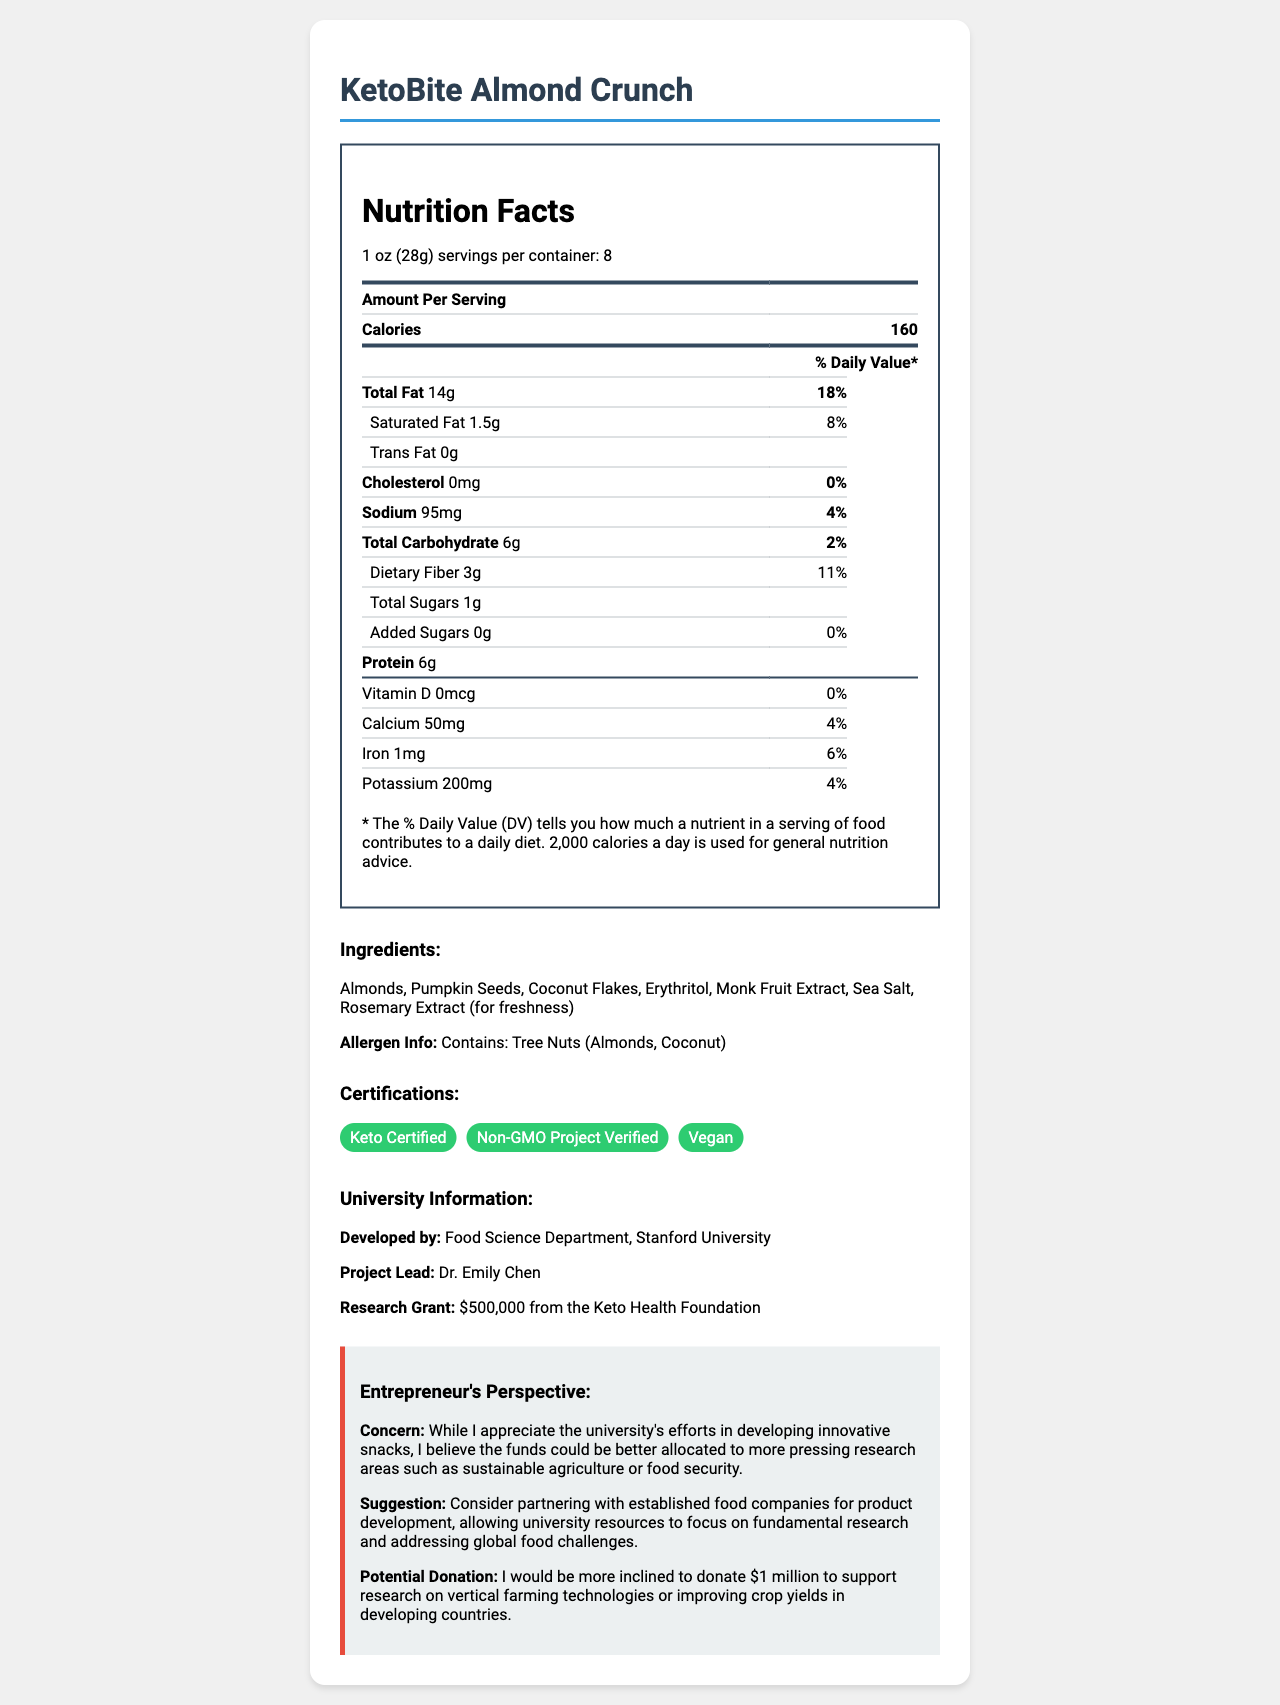what is the product name? The product name is listed at the top of the document.
Answer: KetoBite Almond Crunch how many servings are there per container? The document states that there are 8 servings per container.
Answer: 8 what is the amount of total fat per serving? The nutrition label lists the total fat as 14g per serving.
Answer: 14g which ingredients are used in the KetoBite Almond Crunch? The ingredients are listed under the "Ingredients" section.
Answer: Almonds, Pumpkin Seeds, Coconut Flakes, Erythritol, Monk Fruit Extract, Sea Salt, Rosemary Extract (for freshness) how much protein does each serving contain? The nutrition facts label specifies that there is 6g of protein per serving.
Answer: 6g which university developed this product? The university information section indicates that the product was developed by the Food Science Department at Stanford University.
Answer: Stanford University what is the research grant for the project? A. $100,000 B. $500,000 C. $1,000,000 D. $2,000,000 The university information section states that the research grant was $500,000 from the Keto Health Foundation.
Answer: B. $500,000 how much potassium is in each serving? A. 100mg B. 150mg C. 200mg D. 250mg The nutrition label lists 200mg of potassium per serving.
Answer: C. 200mg is the KetoBite Almond Crunch product vegan? The document includes a certification section which indicates that the product is Vegan.
Answer: Yes describe the entrepreneur's perspective provided in the document. The entrepreneur’s perspective is detailed in the section labeled "Entrepreneur's Perspective," discussing their concerns, suggestions, and potential donation.
Answer: The entrepreneur appreciates the university’s effort in developing innovative snacks but believes the funds could be better used in other research areas like sustainable agriculture or food security. The entrepreneur suggests partnering with established food companies to allow the university to focus on fundamental research. They would consider donating $1 million for vertical farming technologies or crop yield improvements in developing countries. does the product contain any trans fat? The nutrition facts indicate that the product contains 0g of trans fat per serving.
Answer: No how many certifications does the product have? The certifications section shows that the product has three certifications: Keto Certified, Non-GMO Project Verified, and Vegan.
Answer: 3 what is the main idea of the document? The document aims to inform about the KetoBite Almond Crunch, covering various aspects from nutrition to development and the entrepreneur's perspective on future funding priorities.
Answer: The document provides detailed information on the KetoBite Almond Crunch, including its nutrition facts, ingredients, allergen information, certifications, and development details by Stanford University’s Food Science Department. It also includes the perspective of an entrepreneur on the allocation of research funds and potential donation interests. what are the serving size and calories per serving? The serving size and calories per serving are listed at the beginning of the nutrition facts section.
Answer: 1 oz (28g) and 160 calories how many grams of dietary fiber are in one serving? The dietary fiber content per serving is listed as 3g in the nutrition facts section.
Answer: 3g what is the daily value percentage of saturated fat? The nutrition facts label indicates that the daily value percentage for saturated fat is 8%.
Answer: 8% who is the project lead for the development of KetoBite Almond Crunch? The university information section states that Dr. Emily Chen is the project lead.
Answer: Dr. Emily Chen how does the entrepreneur suggest reallocating the funds? The entrepreneur's suggestion is provided in their perspective section, focusing on reallocating funds to more pressing global food challenges.
Answer: Partner with established food companies for product development, and focus university resources on fundamental research and addressing global food challenges. how many grams of added sugars does each serving contain? The nutrition facts indicate that there are 0g of added sugars per serving.
Answer: 0g who funded the research grant for the KetoBite Almond Crunch project? The university information section mentions that the research grant was provided by the Keto Health Foundation.
Answer: Keto Health Foundation what certifications does the product hold? The certifications section lists these three certifications for the product.
Answer: Keto Certified, Non-GMO Project Verified, Vegan how many different tree nuts are mentioned in the allergen information? The allergen information mentions two tree nuts: almonds and coconut.
Answer: 2 what potential donation amount does the entrepreneur mention? The entrepreneur mentions a potential $1 million donation to support research on vertical farming technologies or improving crop yields in developing countries.
Answer: $1 million how much calcium is in one serving? The nutrition facts label indicates the calcium content is 50mg per serving.
Answer: 50mg what is the daily value percentage of sodium? The sodium’s daily value percentage is listed as 4% in the nutrition facts section.
Answer: 4% what is the primary focus of the document? The primary focus is detailed throughout the document, covering various aspects from nutritional information to development and funding perspectives.
Answer: The document primarily focuses on providing comprehensive information about the KetoBite Almond Crunch, including its nutritional details, ingredients, certifications, development by Stanford University, and an entrepreneur’s perspective on funding allocation. how many total carbohydrates are in each serving? The nutrition facts label lists total carbohydrates as 6g per serving.
Answer: 6g who developed the KetoBite Almond Crunch? The university information section states that the Food Science Department at Stanford University developed the product.
Answer: Food Science Department, Stanford University how much vitamin D is present in each serving? The nutrition facts label indicates that there is 0mcg of vitamin D per serving.
Answer: 0mcg which ingredients are used for sweetness in KetoBite Almond Crunch? The ingredients list includes erythritol and monk fruit extract, which are commonly used as sweeteners.
Answer: Erythritol, Monk Fruit Extract how much iron is in one serving? The nutrition facts label lists iron content as 1mg per serving.
Answer: 1mg how much funding does the entrepreneur believe would be better allocated toward sustainable agriculture and food security research? The document does not specify any funding amount the entrepreneur believes should be allocated toward sustainable agriculture and food security research.
Answer: Cannot be determined 